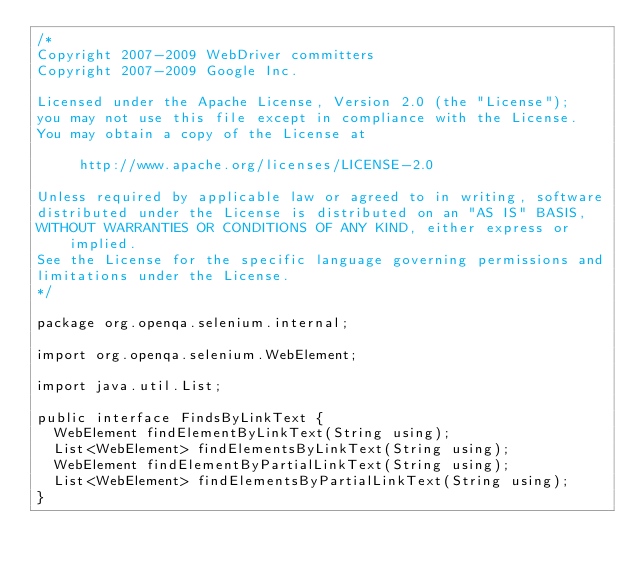Convert code to text. <code><loc_0><loc_0><loc_500><loc_500><_Java_>/*
Copyright 2007-2009 WebDriver committers
Copyright 2007-2009 Google Inc.

Licensed under the Apache License, Version 2.0 (the "License");
you may not use this file except in compliance with the License.
You may obtain a copy of the License at

     http://www.apache.org/licenses/LICENSE-2.0

Unless required by applicable law or agreed to in writing, software
distributed under the License is distributed on an "AS IS" BASIS,
WITHOUT WARRANTIES OR CONDITIONS OF ANY KIND, either express or implied.
See the License for the specific language governing permissions and
limitations under the License.
*/

package org.openqa.selenium.internal;

import org.openqa.selenium.WebElement;

import java.util.List;

public interface FindsByLinkText {
  WebElement findElementByLinkText(String using);
  List<WebElement> findElementsByLinkText(String using);
  WebElement findElementByPartialLinkText(String using);
  List<WebElement> findElementsByPartialLinkText(String using);
}
</code> 